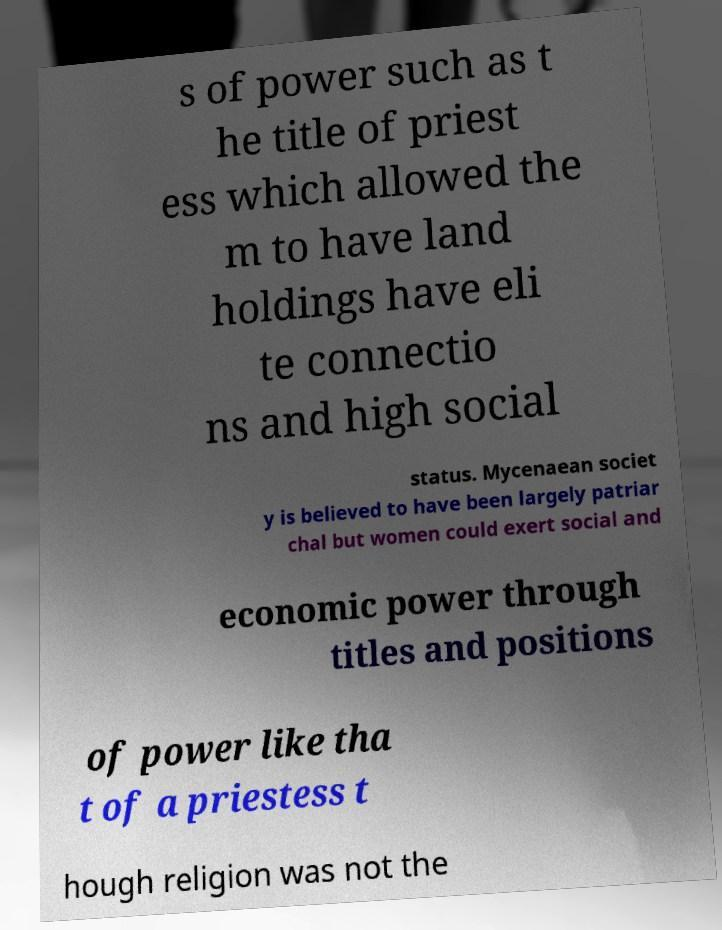Can you accurately transcribe the text from the provided image for me? s of power such as t he title of priest ess which allowed the m to have land holdings have eli te connectio ns and high social status. Mycenaean societ y is believed to have been largely patriar chal but women could exert social and economic power through titles and positions of power like tha t of a priestess t hough religion was not the 